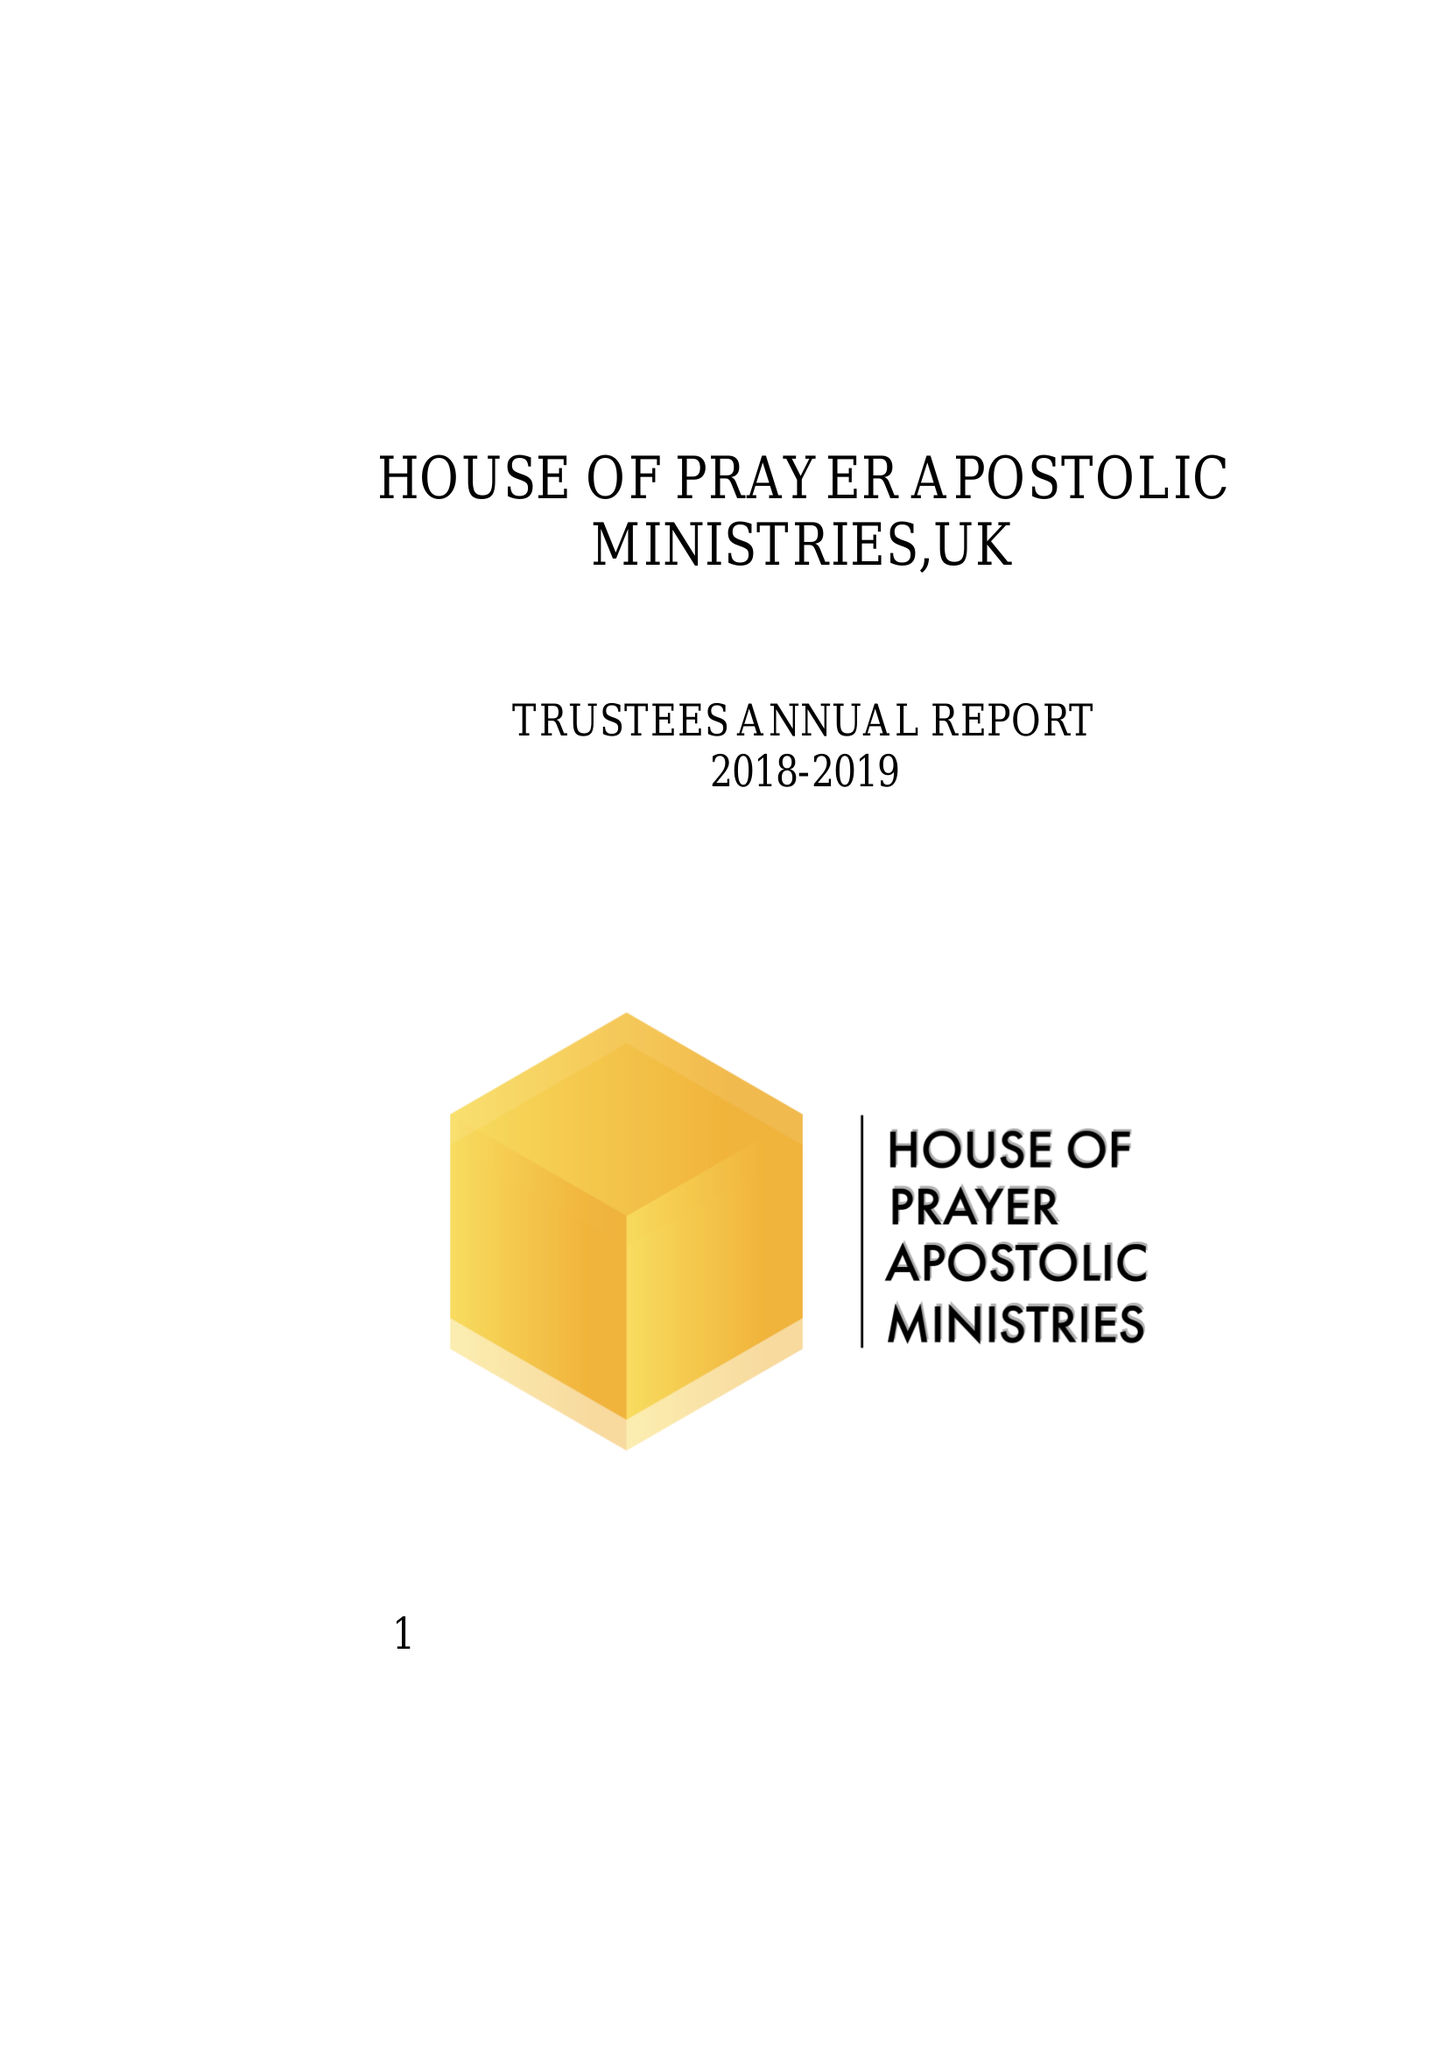What is the value for the address__post_town?
Answer the question using a single word or phrase. DARLINGTON 